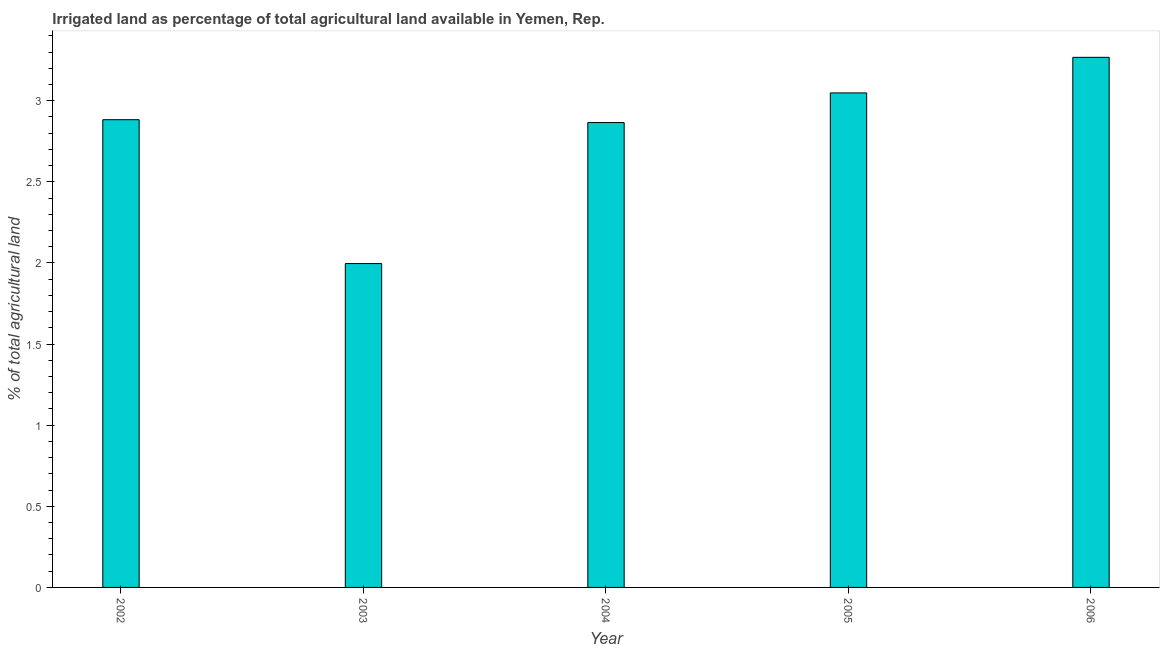Does the graph contain any zero values?
Keep it short and to the point. No. What is the title of the graph?
Make the answer very short. Irrigated land as percentage of total agricultural land available in Yemen, Rep. What is the label or title of the X-axis?
Offer a terse response. Year. What is the label or title of the Y-axis?
Your answer should be very brief. % of total agricultural land. What is the percentage of agricultural irrigated land in 2006?
Ensure brevity in your answer.  3.27. Across all years, what is the maximum percentage of agricultural irrigated land?
Your answer should be compact. 3.27. Across all years, what is the minimum percentage of agricultural irrigated land?
Offer a terse response. 2. What is the sum of the percentage of agricultural irrigated land?
Give a very brief answer. 14.06. What is the difference between the percentage of agricultural irrigated land in 2002 and 2004?
Offer a terse response. 0.02. What is the average percentage of agricultural irrigated land per year?
Your answer should be very brief. 2.81. What is the median percentage of agricultural irrigated land?
Provide a short and direct response. 2.88. In how many years, is the percentage of agricultural irrigated land greater than 3.1 %?
Offer a terse response. 1. Do a majority of the years between 2002 and 2006 (inclusive) have percentage of agricultural irrigated land greater than 1.8 %?
Provide a short and direct response. Yes. What is the ratio of the percentage of agricultural irrigated land in 2003 to that in 2006?
Offer a terse response. 0.61. Is the percentage of agricultural irrigated land in 2004 less than that in 2006?
Your answer should be very brief. Yes. What is the difference between the highest and the second highest percentage of agricultural irrigated land?
Offer a terse response. 0.22. What is the difference between the highest and the lowest percentage of agricultural irrigated land?
Offer a terse response. 1.27. In how many years, is the percentage of agricultural irrigated land greater than the average percentage of agricultural irrigated land taken over all years?
Your response must be concise. 4. How many bars are there?
Offer a terse response. 5. How many years are there in the graph?
Provide a succinct answer. 5. What is the difference between two consecutive major ticks on the Y-axis?
Ensure brevity in your answer.  0.5. What is the % of total agricultural land in 2002?
Your response must be concise. 2.88. What is the % of total agricultural land in 2003?
Offer a very short reply. 2. What is the % of total agricultural land in 2004?
Your response must be concise. 2.87. What is the % of total agricultural land in 2005?
Offer a very short reply. 3.05. What is the % of total agricultural land of 2006?
Offer a very short reply. 3.27. What is the difference between the % of total agricultural land in 2002 and 2003?
Ensure brevity in your answer.  0.89. What is the difference between the % of total agricultural land in 2002 and 2004?
Give a very brief answer. 0.02. What is the difference between the % of total agricultural land in 2002 and 2005?
Your answer should be compact. -0.17. What is the difference between the % of total agricultural land in 2002 and 2006?
Your answer should be very brief. -0.38. What is the difference between the % of total agricultural land in 2003 and 2004?
Offer a very short reply. -0.87. What is the difference between the % of total agricultural land in 2003 and 2005?
Give a very brief answer. -1.05. What is the difference between the % of total agricultural land in 2003 and 2006?
Ensure brevity in your answer.  -1.27. What is the difference between the % of total agricultural land in 2004 and 2005?
Provide a succinct answer. -0.18. What is the difference between the % of total agricultural land in 2004 and 2006?
Ensure brevity in your answer.  -0.4. What is the difference between the % of total agricultural land in 2005 and 2006?
Offer a terse response. -0.22. What is the ratio of the % of total agricultural land in 2002 to that in 2003?
Your response must be concise. 1.44. What is the ratio of the % of total agricultural land in 2002 to that in 2004?
Provide a short and direct response. 1.01. What is the ratio of the % of total agricultural land in 2002 to that in 2005?
Keep it short and to the point. 0.95. What is the ratio of the % of total agricultural land in 2002 to that in 2006?
Give a very brief answer. 0.88. What is the ratio of the % of total agricultural land in 2003 to that in 2004?
Your answer should be very brief. 0.7. What is the ratio of the % of total agricultural land in 2003 to that in 2005?
Provide a short and direct response. 0.66. What is the ratio of the % of total agricultural land in 2003 to that in 2006?
Provide a succinct answer. 0.61. What is the ratio of the % of total agricultural land in 2004 to that in 2005?
Keep it short and to the point. 0.94. What is the ratio of the % of total agricultural land in 2004 to that in 2006?
Provide a succinct answer. 0.88. What is the ratio of the % of total agricultural land in 2005 to that in 2006?
Provide a succinct answer. 0.93. 